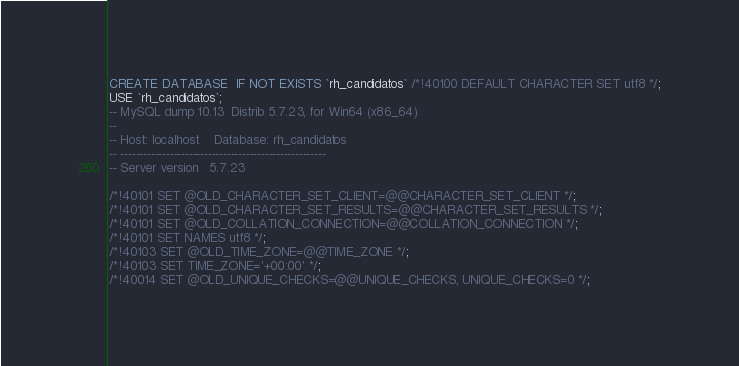Convert code to text. <code><loc_0><loc_0><loc_500><loc_500><_SQL_>CREATE DATABASE  IF NOT EXISTS `rh_candidatos` /*!40100 DEFAULT CHARACTER SET utf8 */;
USE `rh_candidatos`;
-- MySQL dump 10.13  Distrib 5.7.23, for Win64 (x86_64)
--
-- Host: localhost    Database: rh_candidatos
-- ------------------------------------------------------
-- Server version	5.7.23

/*!40101 SET @OLD_CHARACTER_SET_CLIENT=@@CHARACTER_SET_CLIENT */;
/*!40101 SET @OLD_CHARACTER_SET_RESULTS=@@CHARACTER_SET_RESULTS */;
/*!40101 SET @OLD_COLLATION_CONNECTION=@@COLLATION_CONNECTION */;
/*!40101 SET NAMES utf8 */;
/*!40103 SET @OLD_TIME_ZONE=@@TIME_ZONE */;
/*!40103 SET TIME_ZONE='+00:00' */;
/*!40014 SET @OLD_UNIQUE_CHECKS=@@UNIQUE_CHECKS, UNIQUE_CHECKS=0 */;</code> 